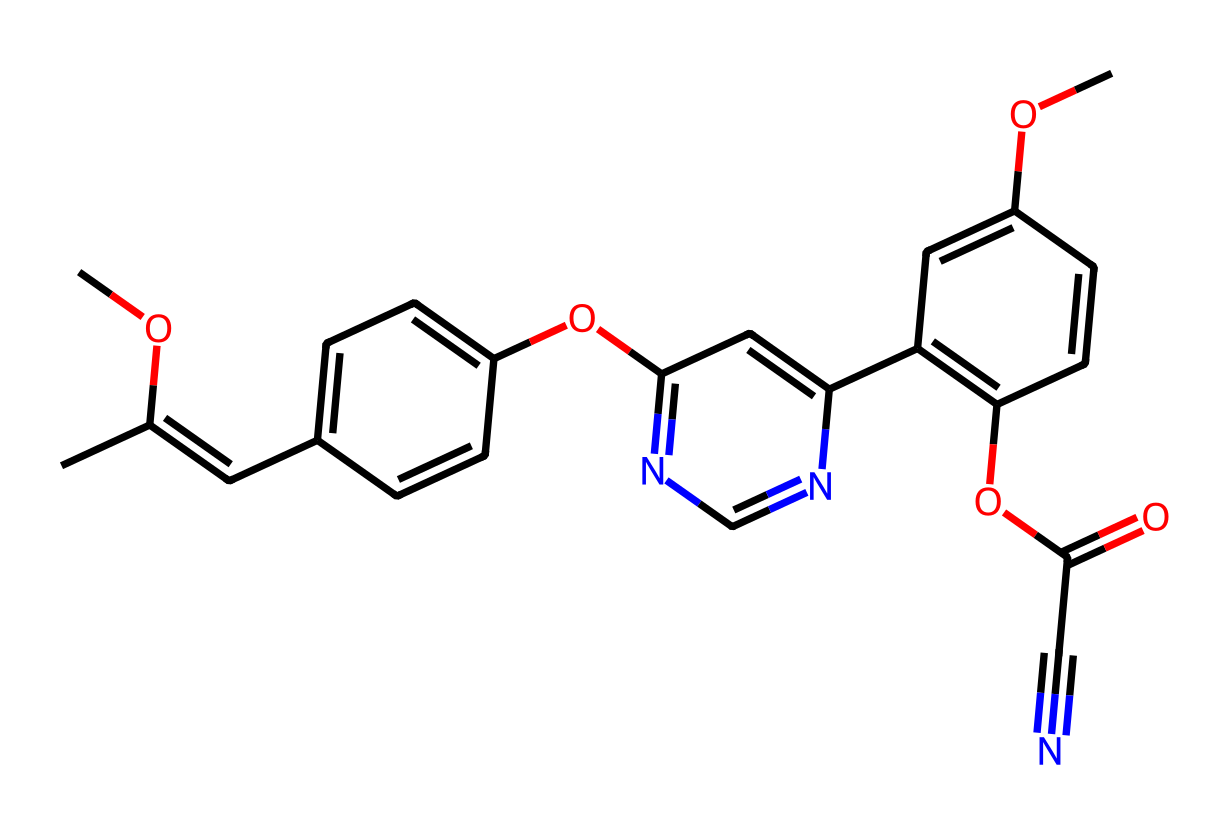What is the total number of carbon atoms in azoxystrobin? By inspecting the chemical structure, I can count all the carbon atoms present in the SMILES representation. Counting carefully reveals that there are a total of 17 carbon atoms.
Answer: 17 How many nitrogen atoms are present in the structure of azoxystrobin? In the given SMILES representation, I can identify the nitrogen atoms by looking for 'N'. I count a total of 2 nitrogen atoms in the structure.
Answer: 2 Identify the functional group indicated by the presence of "OC(=O)" in the structure. The "OC(=O)" portion of the structure suggests that there is an ester or carboxylic acid functional group because the carbon is double-bonded to an oxygen and single-bonded to another oxygen, which connects to the rest of the molecule.
Answer: ester What is the molecular weight of azoxystrobin primarily influenced by? The molecular weight is primarily influenced by the total number of carbon, hydrogen, nitrogen, and oxygen atoms present in the structure, as the contribution of individual atom weights adds up to determine the overall molecular weight.
Answer: atom counts Does azoxystrobin contain a cyanide functional group? Observing the structure, the presence of "C#N" indicates a carbon triple-bonded to a nitrogen, which is characteristic of a cyanide functional group.
Answer: yes What type of compound is azoxystrobin classified as? Given that azoxystrobin is used primarily as a fungicide and characterized by its multi-ring structure and specific functional groups, it is classified as a fungicide.
Answer: fungicide How many rings are present in the azoxystrobin structure? By analyzing the structure, I can identify the presence of three distinct ring systems based on the connectivity and cyclic structure. Counting them one by one confirms that there are 3 rings present.
Answer: 3 